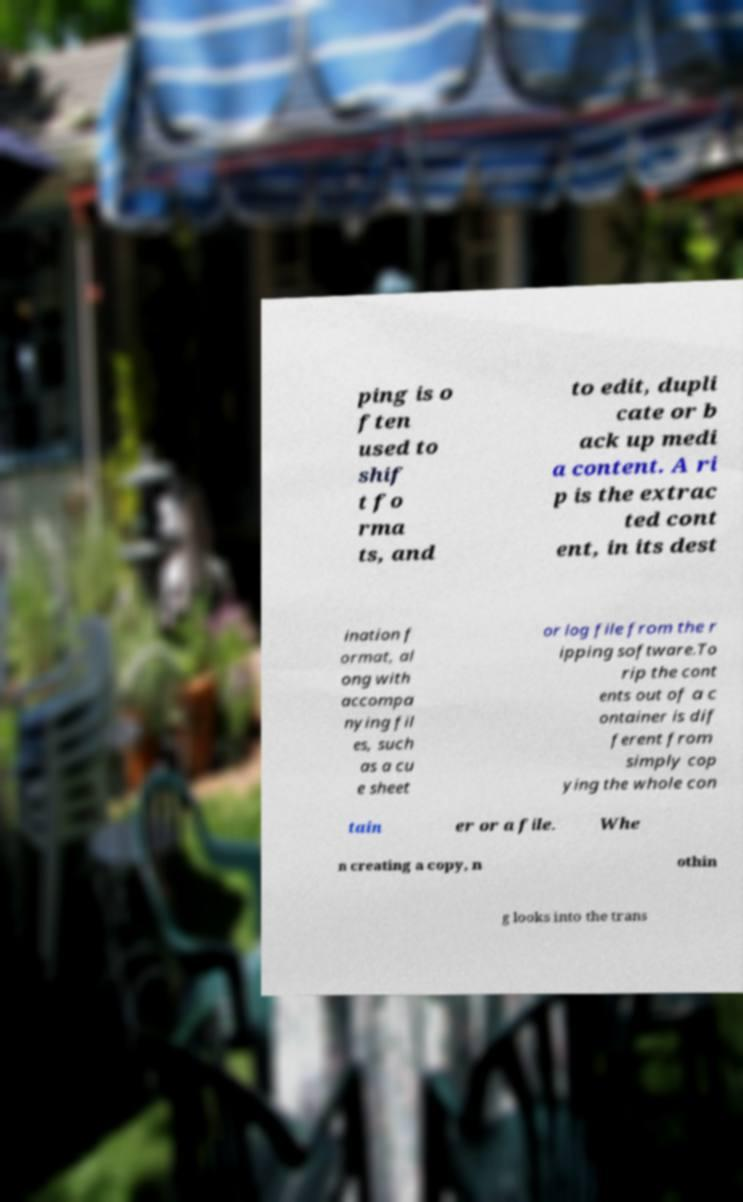Could you assist in decoding the text presented in this image and type it out clearly? ping is o ften used to shif t fo rma ts, and to edit, dupli cate or b ack up medi a content. A ri p is the extrac ted cont ent, in its dest ination f ormat, al ong with accompa nying fil es, such as a cu e sheet or log file from the r ipping software.To rip the cont ents out of a c ontainer is dif ferent from simply cop ying the whole con tain er or a file. Whe n creating a copy, n othin g looks into the trans 